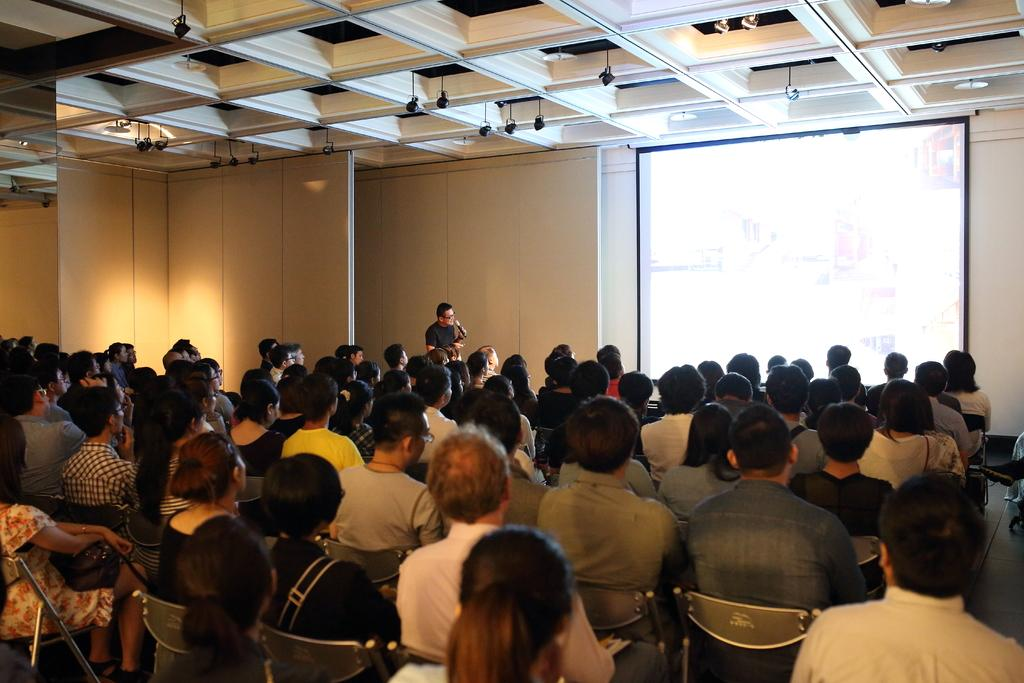What is happening in the room in the image? There are people sitting in the room, and a person is standing and holding a microphone. What is being displayed at the back of the room? There is a projector display at the back of the room. What can be seen at the top of the room? There are lights at the top of the room. What type of watch is the person holding a microphone wearing in the image? There is no watch visible on the person holding the microphone in the image. 